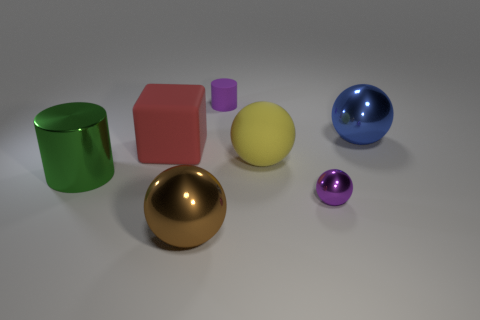Can you comment on the lighting in the image and how it affects the appearance of the objects? The lighting in the image is diffused, casting soft shadows and gentle highlights on the objects. It comes from the upper left, as indicated by the shadows cast towards the lower right. This type of lighting enhances the objects' three-dimensional form without creating harsh glares, and it allows the reflective materials, like on the green cylinder and spheres, to show off their reflective properties quite well. The matte surfaces absorb more light, so they don't reflect but help in appreciating the shape and edges of each object. 